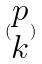Convert formula to latex. <formula><loc_0><loc_0><loc_500><loc_500>( \begin{matrix} p \\ k \end{matrix} )</formula> 